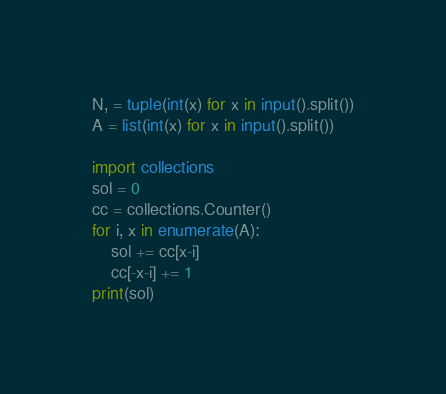<code> <loc_0><loc_0><loc_500><loc_500><_Cython_>N, = tuple(int(x) for x in input().split())
A = list(int(x) for x in input().split())

import collections
sol = 0
cc = collections.Counter()
for i, x in enumerate(A):
    sol += cc[x-i]
    cc[-x-i] += 1
print(sol)
</code> 